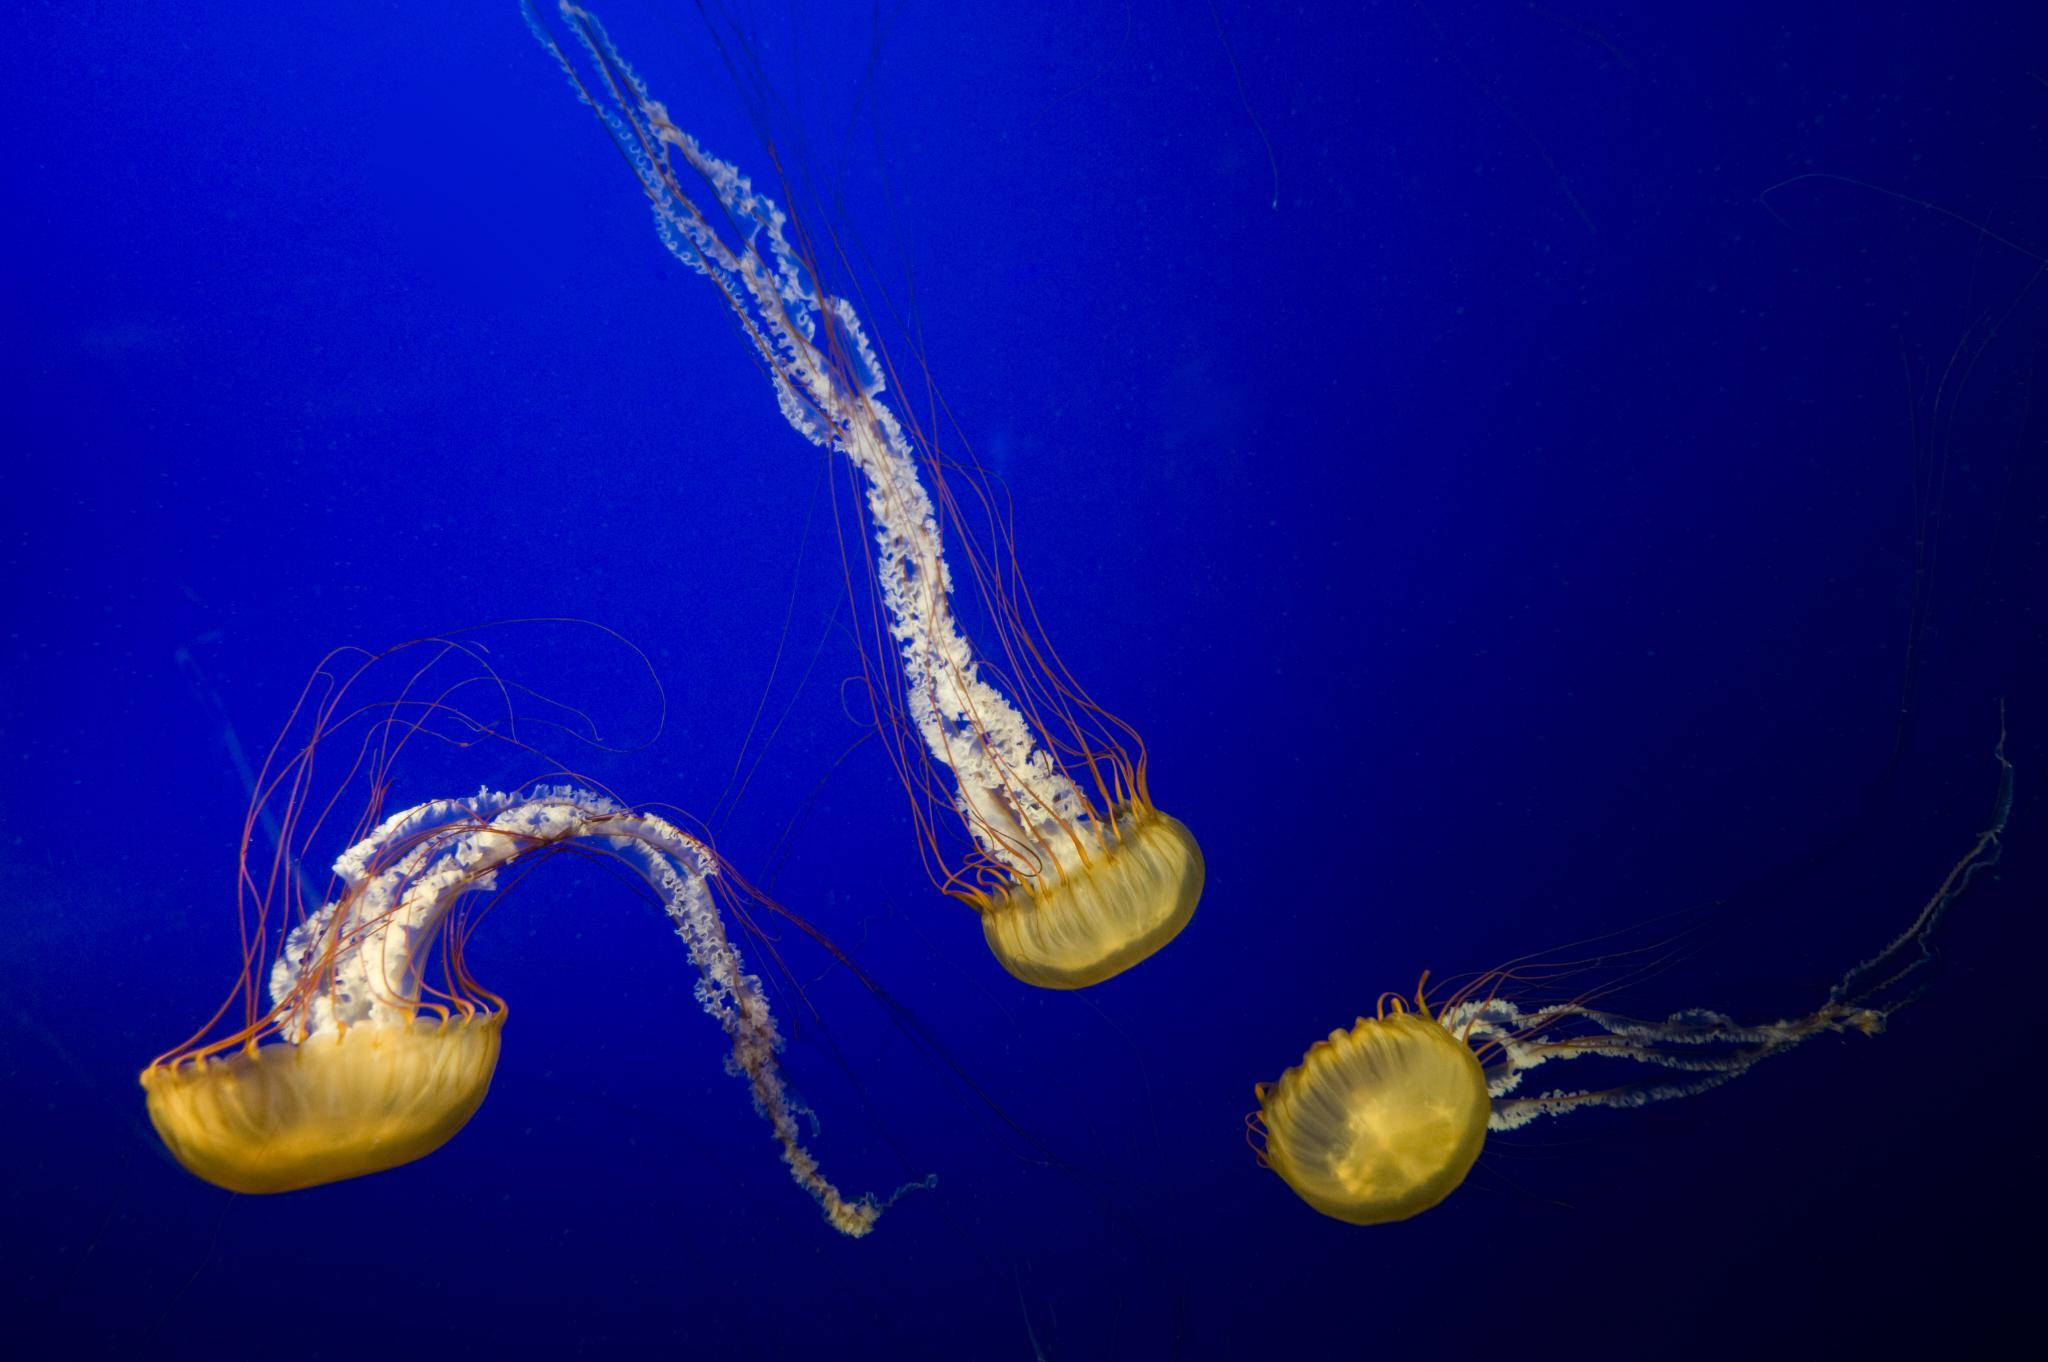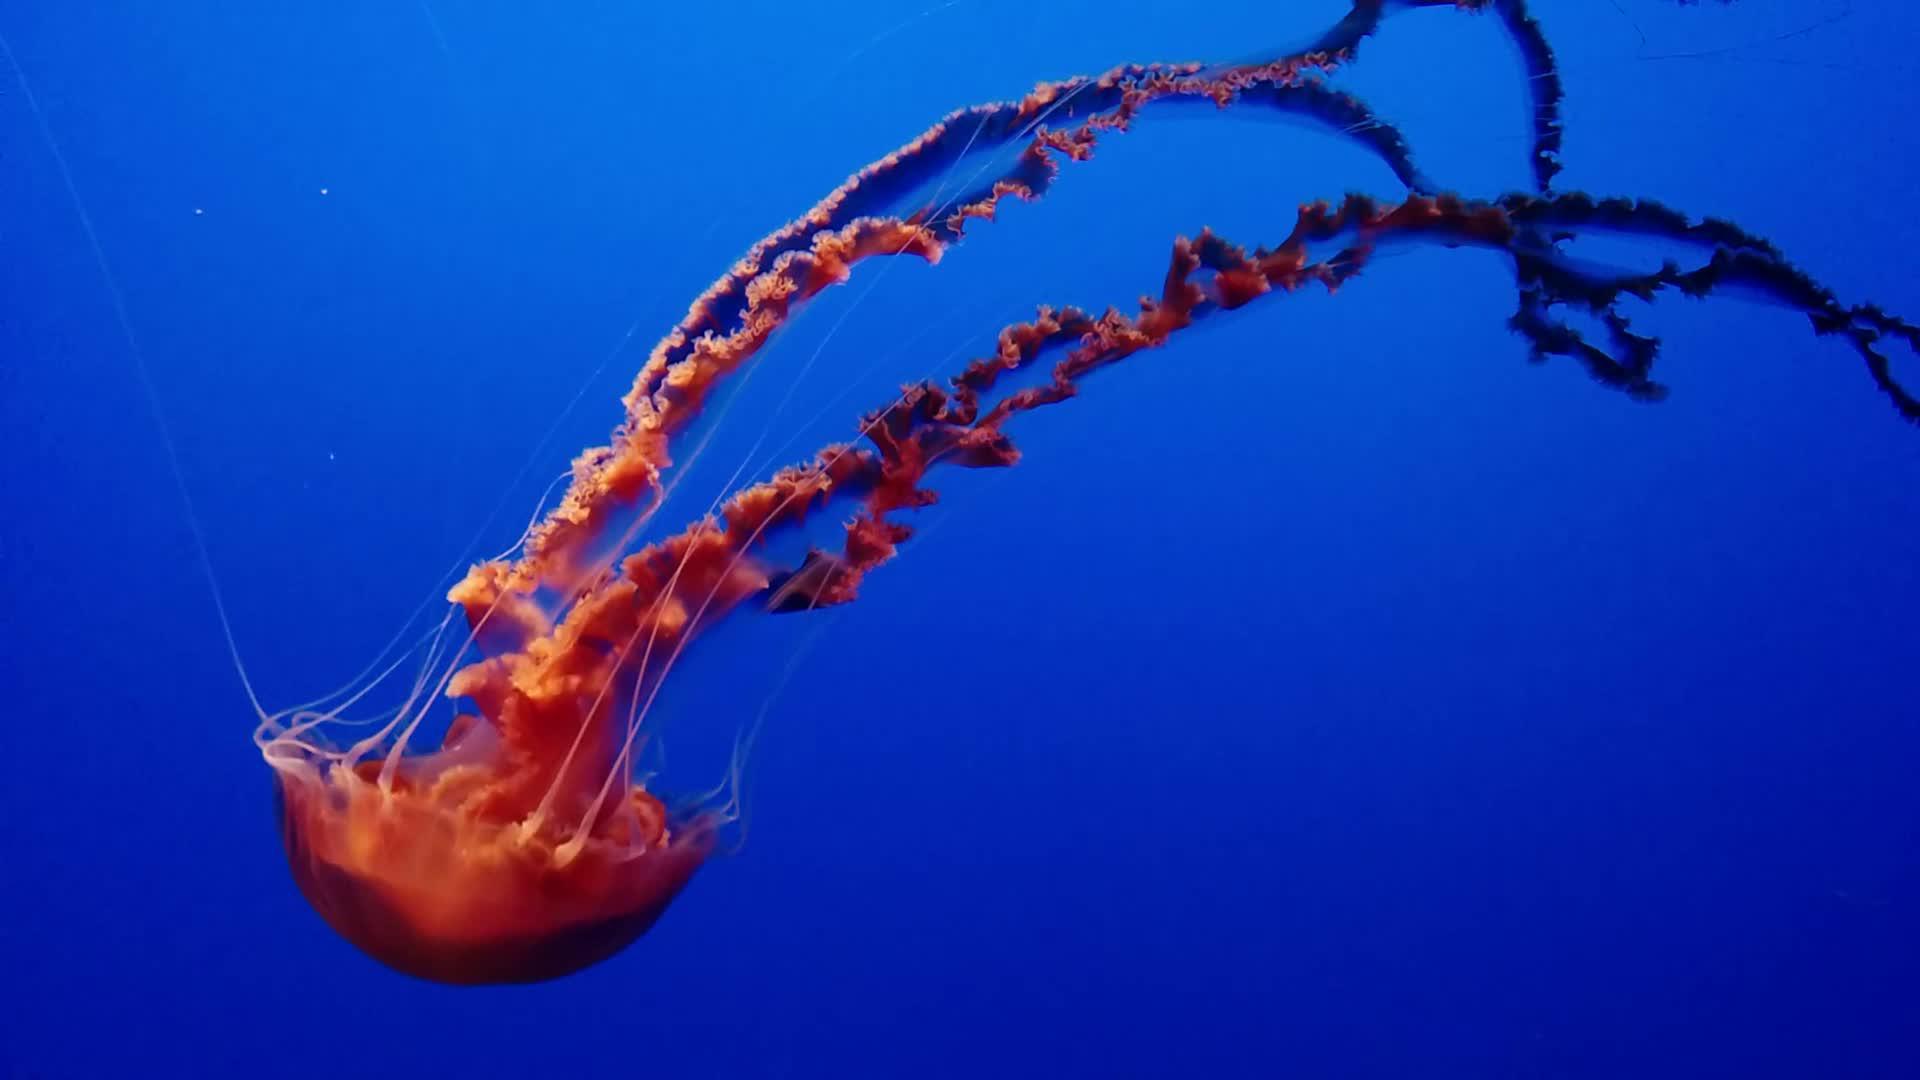The first image is the image on the left, the second image is the image on the right. For the images displayed, is the sentence "One image contains multiple jellyfish, and one image contains a single orange jellyfish with long 'ruffled' tendrils on a solid blue backdrop." factually correct? Answer yes or no. Yes. The first image is the image on the left, the second image is the image on the right. For the images displayed, is the sentence "One jellyfish is swimming toward the right." factually correct? Answer yes or no. No. 